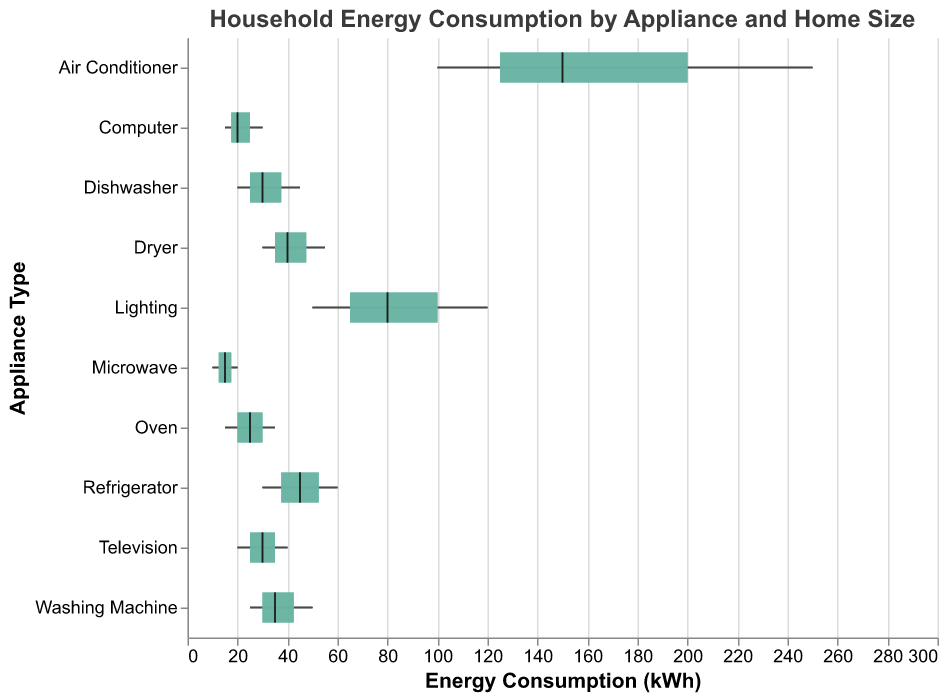What is the title of the plot? The title of the plot is located at the top and reads "Household Energy Consumption by Appliance and Home Size."
Answer: Household Energy Consumption by Appliance and Home Size Which appliance has the highest energy consumption in large homes? To find the appliance with the highest energy consumption, look at the maximum value on the x-axis for 'Large Home kWh' and identify the corresponding appliance. The appliance with the highest value is the Air Conditioner with 250 kWh.
Answer: Air Conditioner What is the median energy consumption for Refrigerators? Locate the tick mark on the x-axis for the Refrigerator row. The median value is represented by the tick mark, which is at 45 kWh.
Answer: 45 kWh Which appliance shows the smallest difference in energy consumption across different home sizes? Identify the appliances with the smallest range between the minimum and maximum values on the x-axis. The smallest difference in energy consumption is for the Microwave, which ranges from 10 kWh to 20 kWh, a difference of 10 kWh.
Answer: Microwave How does the energy consumption for Lighting in small homes compare to that in medium homes? Comparing the 'Small Home kWh' and 'Medium Home kWh' values for Lighting, small homes consume 50 kWh, while medium homes consume 80 kWh. The energy consumption in medium homes is higher by 30 kWh.
Answer: Medium homes consume 30 kWh more What is the range of energy consumption for Washing Machines? The range is calculated as the difference between the maximum (50 kWh) and minimum (25 kWh) values for Washing Machines. The range is 50 - 25 = 25 kWh.
Answer: 25 kWh Which appliances have a lower median energy consumption than the Oven? Identify the median energy consumption and compare values. The Oven's median is 25 kWh, and the appliances with lower medians are Microwave and Computer with 15 kWh each.
Answer: Microwave, Computer What is the interquartile range (IQR) for Dishwashers? The IQR is calculated by subtracting the 1st quartile (20 kWh) from the 3rd quartile (45 kWh). The IQR for Dishwashers is 45 - 20 = 25 kWh.
Answer: 25 kWh Which appliance's energy consumption covers the widest range in small homes? Identify the appliance with the highest value for 'Small Home kWh'. The appliance with the highest value is the Air Conditioner with 100 kWh.
Answer: Air Conditioner What is the median energy consumption for the Dryer compared to the Computer? Locate the median positions for both appliances. The Dryer has a median of 40 kWh, and the Computer has a median of 20 kWh. The Dryer has a higher median energy consumption by 20 kWh.
Answer: Dryer has 20 kWh more 